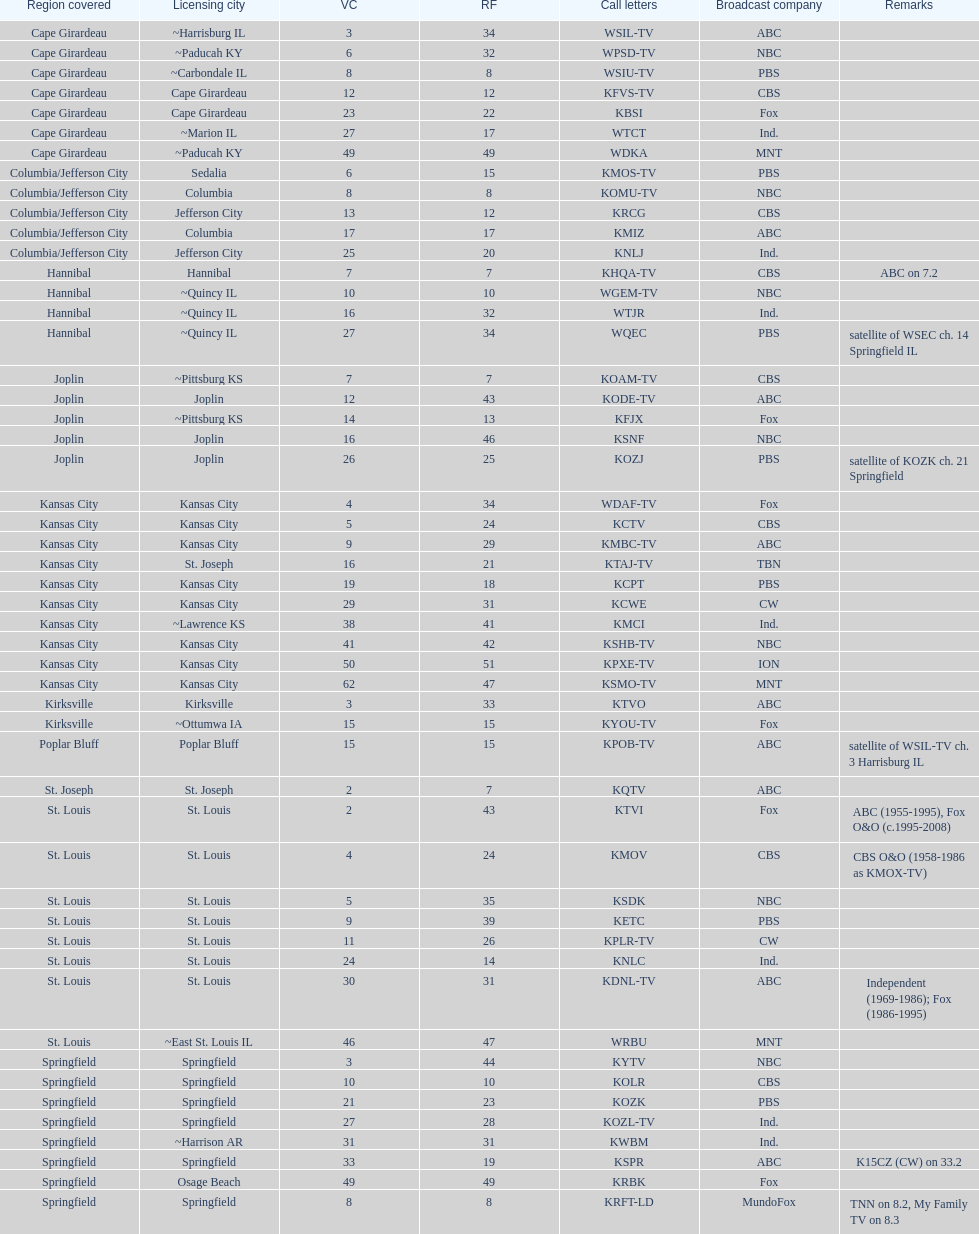Kode-tv and wsil-tv both are a part of which network? ABC. 